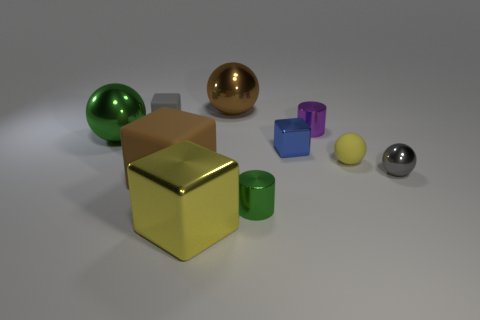There is a brown object behind the large green metal ball; does it have the same size as the cylinder that is on the left side of the purple shiny cylinder?
Offer a terse response. No. How many other objects are the same size as the gray sphere?
Provide a succinct answer. 5. What number of spheres are behind the tiny gray object that is right of the tiny yellow ball?
Your answer should be compact. 3. Are there fewer matte things that are left of the big yellow shiny block than tiny blue blocks?
Provide a short and direct response. No. What is the shape of the green shiny object behind the tiny gray object to the right of the metal block in front of the gray shiny object?
Your answer should be compact. Sphere. Does the yellow shiny thing have the same shape as the blue metal object?
Offer a very short reply. Yes. How many other objects are there of the same shape as the small gray matte thing?
Provide a short and direct response. 3. There is a matte object that is the same size as the rubber ball; what color is it?
Provide a succinct answer. Gray. Is the number of yellow rubber balls left of the green cylinder the same as the number of tiny metal cylinders?
Provide a succinct answer. No. There is a large thing that is in front of the tiny gray ball and right of the brown rubber cube; what shape is it?
Make the answer very short. Cube. 